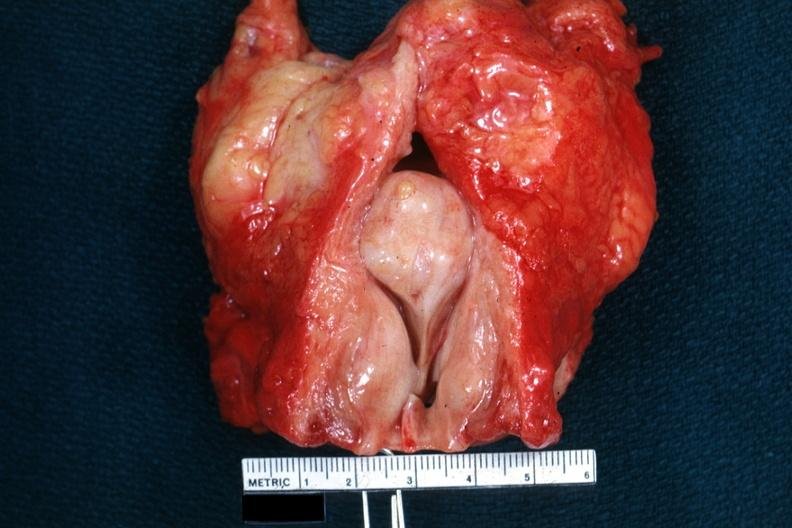s hyperplasia present?
Answer the question using a single word or phrase. Yes 